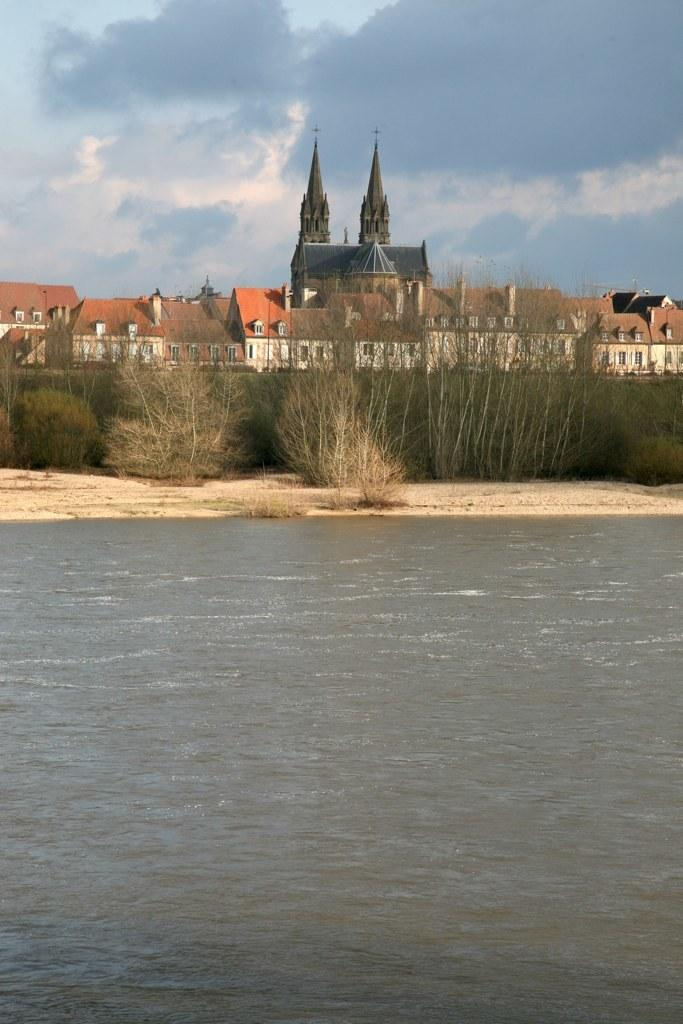What is the primary element visible in the image? There is water in the image. What type of vegetation can be seen on the ground in the image? There are plants on the ground in the image. What structures are visible in the background of the image? There are buildings in the background of the image. What is visible at the top of the image? The sky is visible at the top of the image. How many cows are grazing near the water in the image? There are no cows present in the image; it features water, plants, buildings, and the sky. 